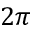<formula> <loc_0><loc_0><loc_500><loc_500>2 \pi</formula> 